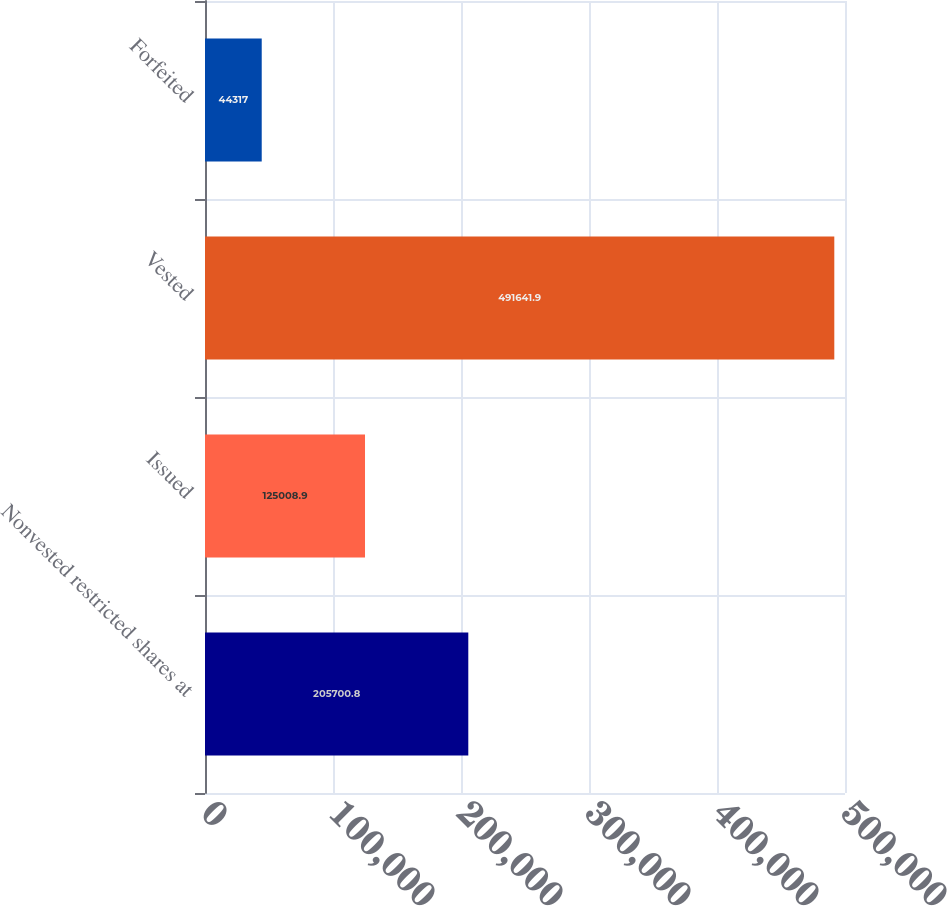Convert chart. <chart><loc_0><loc_0><loc_500><loc_500><bar_chart><fcel>Nonvested restricted shares at<fcel>Issued<fcel>Vested<fcel>Forfeited<nl><fcel>205701<fcel>125009<fcel>491642<fcel>44317<nl></chart> 